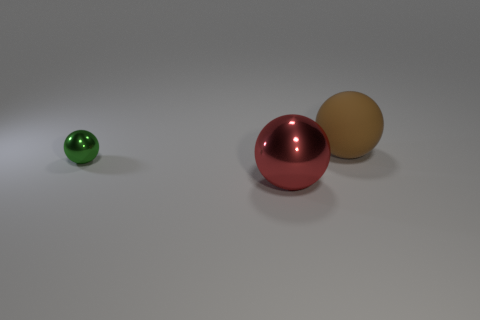Add 1 tiny things. How many objects exist? 4 Subtract all green spheres. How many spheres are left? 2 Subtract 1 spheres. How many spheres are left? 2 Add 2 small green things. How many small green things exist? 3 Subtract all red spheres. How many spheres are left? 2 Subtract 0 cyan blocks. How many objects are left? 3 Subtract all purple balls. Subtract all cyan cylinders. How many balls are left? 3 Subtract all tiny things. Subtract all brown rubber balls. How many objects are left? 1 Add 2 metal spheres. How many metal spheres are left? 4 